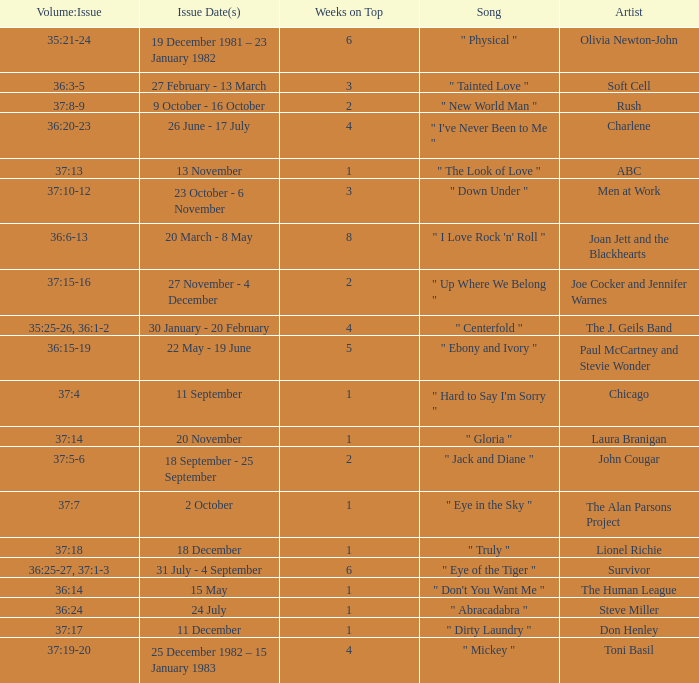Which Weeks on Top have an Issue Date(s) of 20 november? 1.0. 